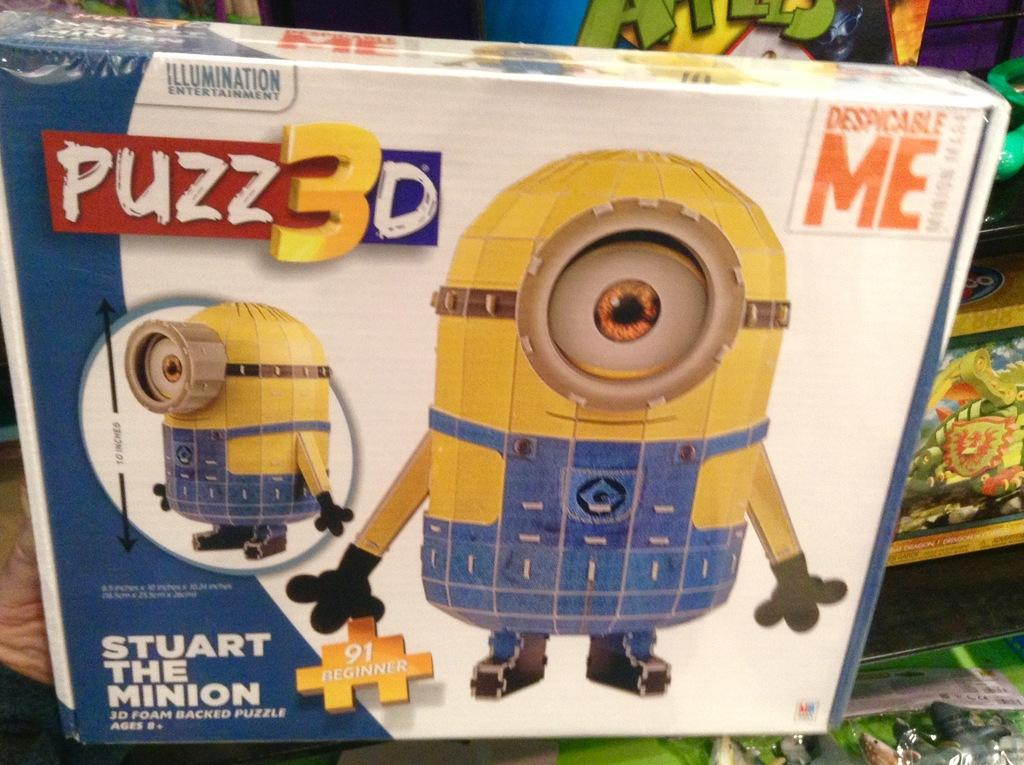What is the main object in the image? There is a puzzle box in the image. What is depicted on the puzzle box? The puzzle box has a toy image on it. Are there any other toys visible in the image? Yes, there are other toys visible behind the box. How many yams are being used as a bath toy in the image? There are no yams or bath toys present in the image. 